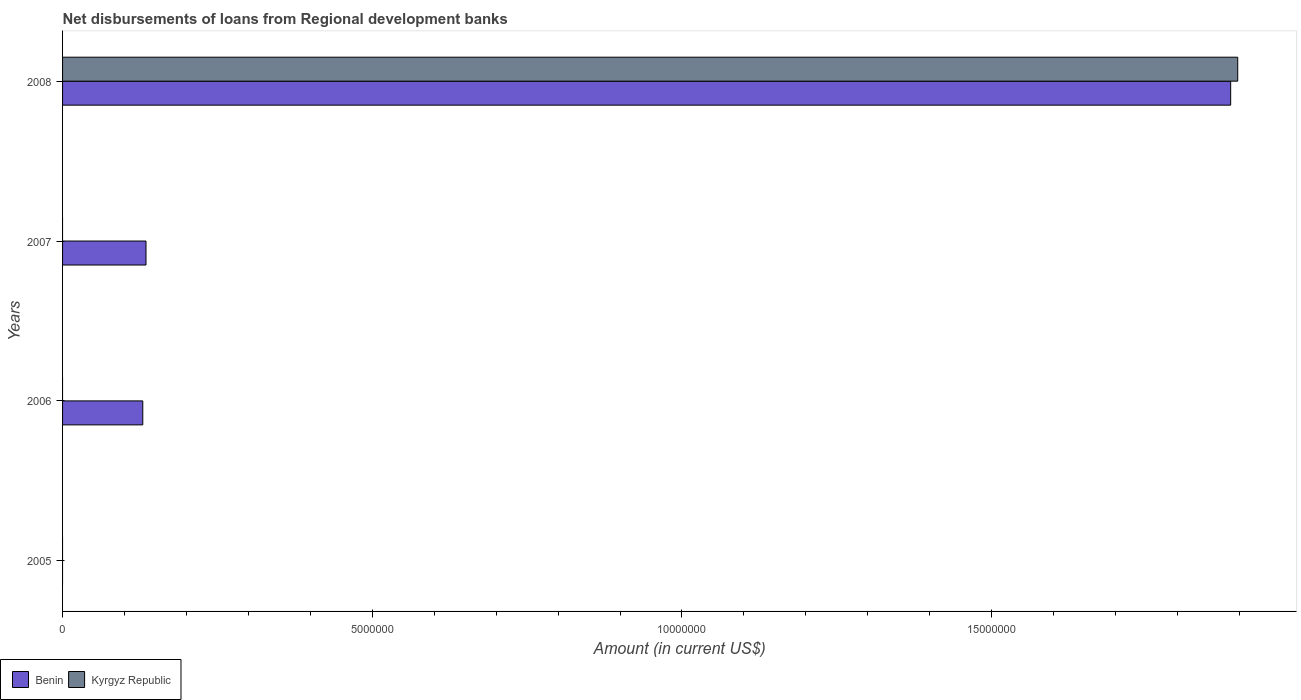How many different coloured bars are there?
Your answer should be compact. 2. Are the number of bars per tick equal to the number of legend labels?
Offer a very short reply. No. How many bars are there on the 3rd tick from the bottom?
Offer a very short reply. 1. What is the label of the 3rd group of bars from the top?
Provide a short and direct response. 2006. What is the amount of disbursements of loans from regional development banks in Benin in 2007?
Your answer should be very brief. 1.35e+06. Across all years, what is the maximum amount of disbursements of loans from regional development banks in Benin?
Offer a very short reply. 1.89e+07. In which year was the amount of disbursements of loans from regional development banks in Benin maximum?
Ensure brevity in your answer.  2008. What is the total amount of disbursements of loans from regional development banks in Kyrgyz Republic in the graph?
Provide a short and direct response. 1.90e+07. What is the difference between the amount of disbursements of loans from regional development banks in Benin in 2006 and that in 2007?
Ensure brevity in your answer.  -5.20e+04. What is the difference between the amount of disbursements of loans from regional development banks in Benin in 2006 and the amount of disbursements of loans from regional development banks in Kyrgyz Republic in 2008?
Your response must be concise. -1.77e+07. What is the average amount of disbursements of loans from regional development banks in Kyrgyz Republic per year?
Offer a very short reply. 4.74e+06. In the year 2008, what is the difference between the amount of disbursements of loans from regional development banks in Kyrgyz Republic and amount of disbursements of loans from regional development banks in Benin?
Provide a short and direct response. 1.14e+05. What is the difference between the highest and the second highest amount of disbursements of loans from regional development banks in Benin?
Your response must be concise. 1.75e+07. What is the difference between the highest and the lowest amount of disbursements of loans from regional development banks in Benin?
Provide a succinct answer. 1.89e+07. What is the difference between two consecutive major ticks on the X-axis?
Ensure brevity in your answer.  5.00e+06. Does the graph contain any zero values?
Provide a succinct answer. Yes. Where does the legend appear in the graph?
Provide a succinct answer. Bottom left. What is the title of the graph?
Provide a short and direct response. Net disbursements of loans from Regional development banks. Does "China" appear as one of the legend labels in the graph?
Ensure brevity in your answer.  No. What is the label or title of the X-axis?
Ensure brevity in your answer.  Amount (in current US$). What is the Amount (in current US$) of Benin in 2005?
Your answer should be compact. 0. What is the Amount (in current US$) of Benin in 2006?
Give a very brief answer. 1.30e+06. What is the Amount (in current US$) of Kyrgyz Republic in 2006?
Ensure brevity in your answer.  0. What is the Amount (in current US$) in Benin in 2007?
Provide a short and direct response. 1.35e+06. What is the Amount (in current US$) in Benin in 2008?
Ensure brevity in your answer.  1.89e+07. What is the Amount (in current US$) of Kyrgyz Republic in 2008?
Provide a succinct answer. 1.90e+07. Across all years, what is the maximum Amount (in current US$) of Benin?
Provide a succinct answer. 1.89e+07. Across all years, what is the maximum Amount (in current US$) of Kyrgyz Republic?
Offer a terse response. 1.90e+07. Across all years, what is the minimum Amount (in current US$) of Benin?
Provide a short and direct response. 0. Across all years, what is the minimum Amount (in current US$) in Kyrgyz Republic?
Your answer should be compact. 0. What is the total Amount (in current US$) of Benin in the graph?
Keep it short and to the point. 2.15e+07. What is the total Amount (in current US$) of Kyrgyz Republic in the graph?
Provide a succinct answer. 1.90e+07. What is the difference between the Amount (in current US$) in Benin in 2006 and that in 2007?
Provide a succinct answer. -5.20e+04. What is the difference between the Amount (in current US$) in Benin in 2006 and that in 2008?
Give a very brief answer. -1.76e+07. What is the difference between the Amount (in current US$) in Benin in 2007 and that in 2008?
Provide a succinct answer. -1.75e+07. What is the difference between the Amount (in current US$) of Benin in 2006 and the Amount (in current US$) of Kyrgyz Republic in 2008?
Keep it short and to the point. -1.77e+07. What is the difference between the Amount (in current US$) in Benin in 2007 and the Amount (in current US$) in Kyrgyz Republic in 2008?
Provide a short and direct response. -1.76e+07. What is the average Amount (in current US$) of Benin per year?
Your answer should be compact. 5.38e+06. What is the average Amount (in current US$) of Kyrgyz Republic per year?
Your answer should be very brief. 4.74e+06. In the year 2008, what is the difference between the Amount (in current US$) in Benin and Amount (in current US$) in Kyrgyz Republic?
Your answer should be very brief. -1.14e+05. What is the ratio of the Amount (in current US$) in Benin in 2006 to that in 2007?
Your response must be concise. 0.96. What is the ratio of the Amount (in current US$) of Benin in 2006 to that in 2008?
Keep it short and to the point. 0.07. What is the ratio of the Amount (in current US$) of Benin in 2007 to that in 2008?
Your answer should be very brief. 0.07. What is the difference between the highest and the second highest Amount (in current US$) of Benin?
Your answer should be very brief. 1.75e+07. What is the difference between the highest and the lowest Amount (in current US$) in Benin?
Give a very brief answer. 1.89e+07. What is the difference between the highest and the lowest Amount (in current US$) in Kyrgyz Republic?
Your answer should be compact. 1.90e+07. 